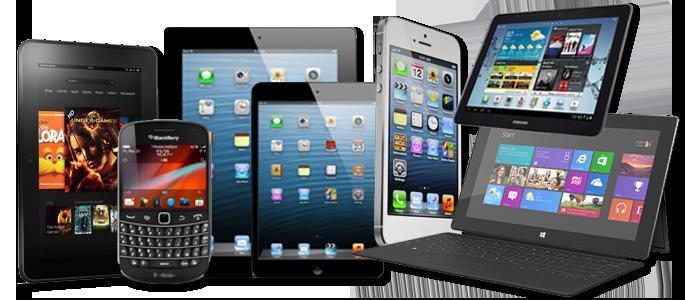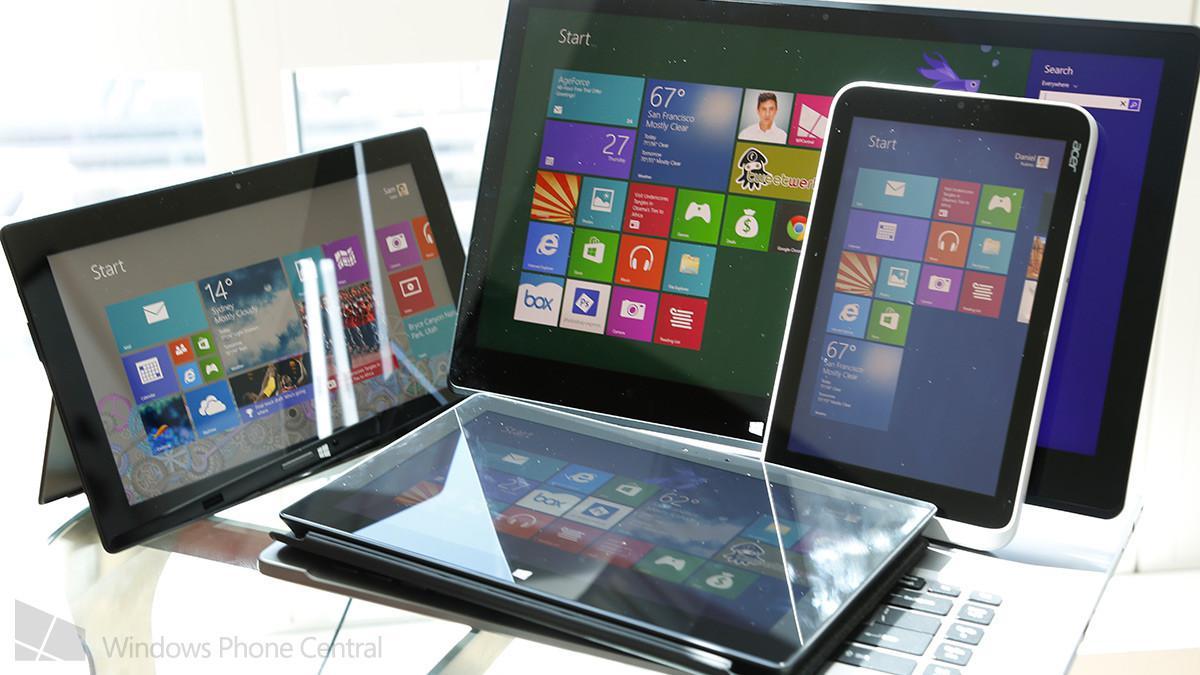The first image is the image on the left, the second image is the image on the right. Considering the images on both sides, is "There are at least four devices visible in each image." valid? Answer yes or no. Yes. 